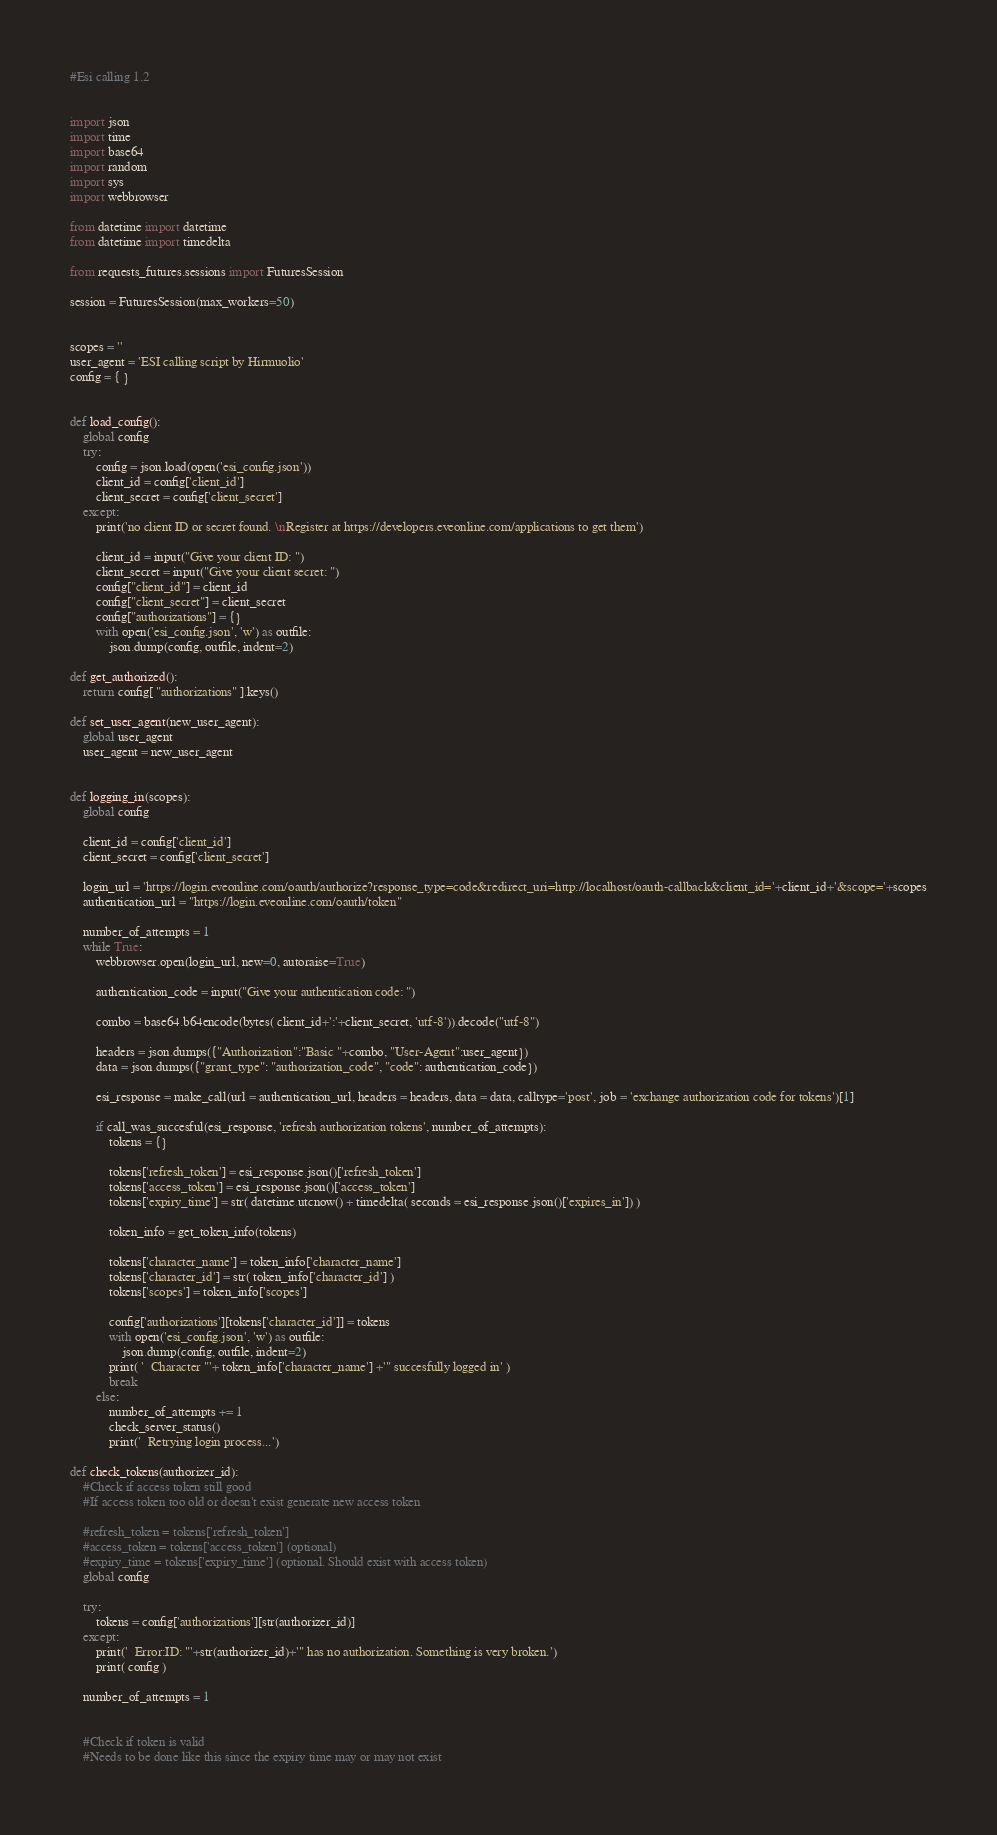Convert code to text. <code><loc_0><loc_0><loc_500><loc_500><_Python_>#Esi calling 1.2


import json
import time
import base64
import random
import sys
import webbrowser

from datetime import datetime
from datetime import timedelta

from requests_futures.sessions import FuturesSession

session = FuturesSession(max_workers=50)


scopes = ''
user_agent = 'ESI calling script by Hirmuolio'
config = { }


def load_config():
	global config
	try:
		config = json.load(open('esi_config.json'))
		client_id = config['client_id']
		client_secret = config['client_secret']
	except:
		print('no client ID or secret found. \nRegister at https://developers.eveonline.com/applications to get them')
		
		client_id = input("Give your client ID: ")
		client_secret = input("Give your client secret: ")
		config["client_id"] = client_id
		config["client_secret"] = client_secret
		config["authorizations"] = {}
		with open('esi_config.json', 'w') as outfile:
			json.dump(config, outfile, indent=2)

def get_authorized():
	return config[ "authorizations" ].keys()

def set_user_agent(new_user_agent):
	global user_agent
	user_agent = new_user_agent

	
def logging_in(scopes):
	global config
	
	client_id = config['client_id']
	client_secret = config['client_secret']
	
	login_url = 'https://login.eveonline.com/oauth/authorize?response_type=code&redirect_uri=http://localhost/oauth-callback&client_id='+client_id+'&scope='+scopes
	authentication_url = "https://login.eveonline.com/oauth/token"
	
	number_of_attempts = 1
	while True:
		webbrowser.open(login_url, new=0, autoraise=True)

		authentication_code = input("Give your authentication code: ")
		
		combo = base64.b64encode(bytes( client_id+':'+client_secret, 'utf-8')).decode("utf-8")
		
		headers = json.dumps({"Authorization":"Basic "+combo, "User-Agent":user_agent})
		data = json.dumps({"grant_type": "authorization_code", "code": authentication_code})
		
		esi_response = make_call(url = authentication_url, headers = headers, data = data, calltype='post', job = 'exchange authorization code for tokens')[1]
		
		if call_was_succesful(esi_response, 'refresh authorization tokens', number_of_attempts):
			tokens = {}
			
			tokens['refresh_token'] = esi_response.json()['refresh_token']
			tokens['access_token'] = esi_response.json()['access_token']
			tokens['expiry_time'] = str( datetime.utcnow() + timedelta( seconds = esi_response.json()['expires_in']) )
			
			token_info = get_token_info(tokens)
			
			tokens['character_name'] = token_info['character_name']
			tokens['character_id'] = str( token_info['character_id'] )
			tokens['scopes'] = token_info['scopes']
			
			config['authorizations'][tokens['character_id']] = tokens
			with open('esi_config.json', 'w') as outfile:
				json.dump(config, outfile, indent=2)
			print( '  Character "'+ token_info['character_name'] +'" succesfully logged in' )
			break
		else:
			number_of_attempts += 1
			check_server_status()
			print('  Retrying login process...')
	
def check_tokens(authorizer_id):
	#Check if access token still good
	#If access token too old or doesn't exist generate new access token
	
	#refresh_token = tokens['refresh_token']
	#access_token = tokens['access_token'] (optional)
	#expiry_time = tokens['expiry_time'] (optional. Should exist with access token)
	global config
	
	try:
		tokens = config['authorizations'][str(authorizer_id)]
	except:
		print('  Error:ID: "'+str(authorizer_id)+'" has no authorization. Something is very broken.')
		print( config )
	
	number_of_attempts = 1
	
	
	#Check if token is valid
	#Needs to be done like this since the expiry time may or may not exist</code> 